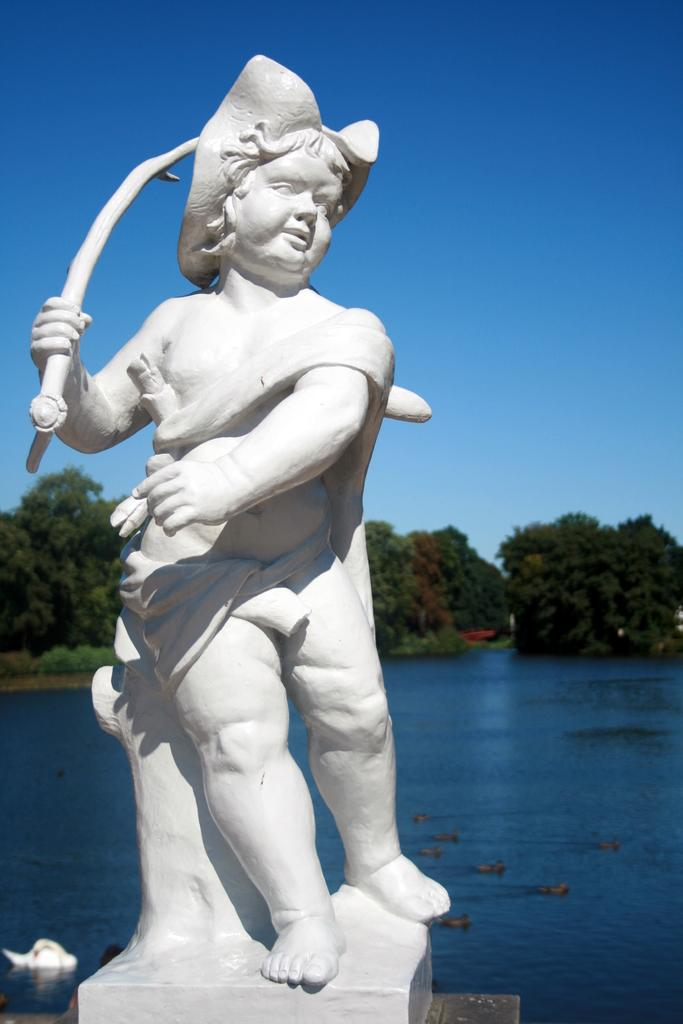What is the main subject of the image? There is a person depicted in the image. What is the person holding in the image? The person is holding something. Can you describe the setting of the image? The setting is in a house. What other objects or features can be seen in the image? There is a statue and a duck on the water in the image. Additionally, there are trees in the background and the sky is visible. What type of cabbage is being used as a beam in the image? There is no cabbage or beam present in the image. 